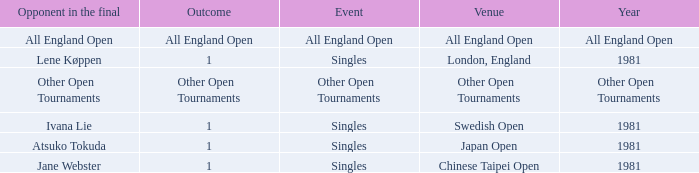Who was the Opponent in London, England with an Outcome of 1? Lene Køppen. I'm looking to parse the entire table for insights. Could you assist me with that? {'header': ['Opponent in the final', 'Outcome', 'Event', 'Venue', 'Year'], 'rows': [['All England Open', 'All England Open', 'All England Open', 'All England Open', 'All England Open'], ['Lene Køppen', '1', 'Singles', 'London, England', '1981'], ['Other Open Tournaments', 'Other Open Tournaments', 'Other Open Tournaments', 'Other Open Tournaments', 'Other Open Tournaments'], ['Ivana Lie', '1', 'Singles', 'Swedish Open', '1981'], ['Atsuko Tokuda', '1', 'Singles', 'Japan Open', '1981'], ['Jane Webster', '1', 'Singles', 'Chinese Taipei Open', '1981']]} 